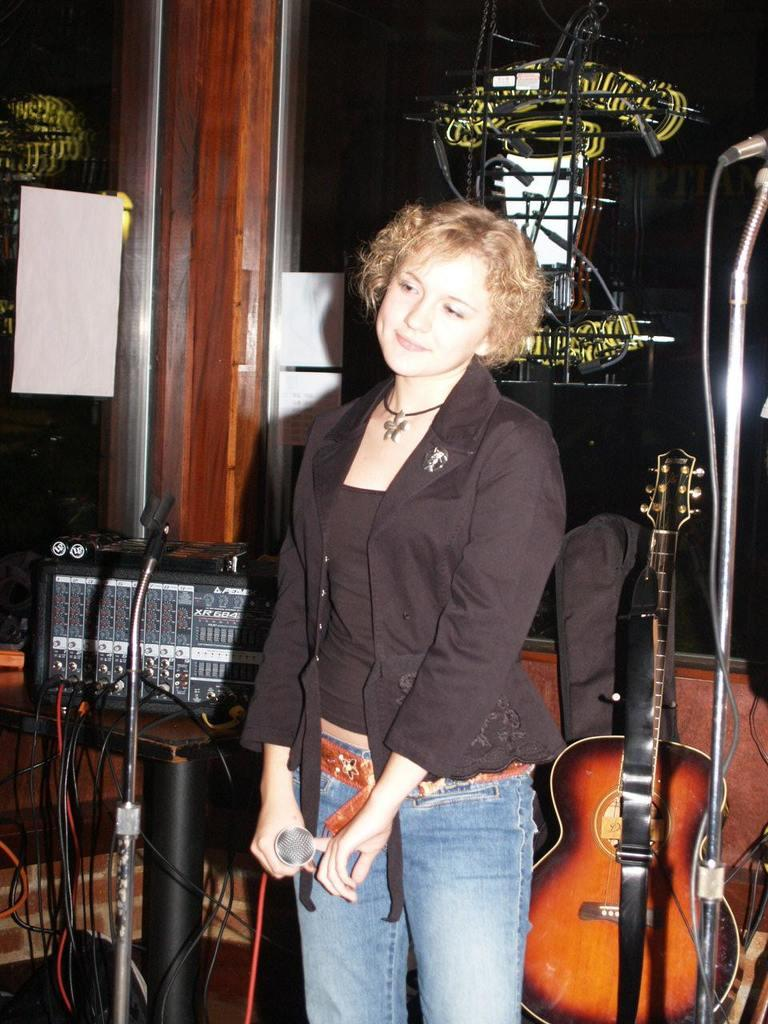Who is the main subject in the image? There is a woman in the image. What is the woman doing in the image? The woman is standing and holding a microphone in her hands. Are there any other objects or instruments visible in the image? Yes, there are musical instruments visible in the image. What type of bean is being discussed in the news on the radio in the image? There is no radio or news mentioned in the image, and no beans are visible. 